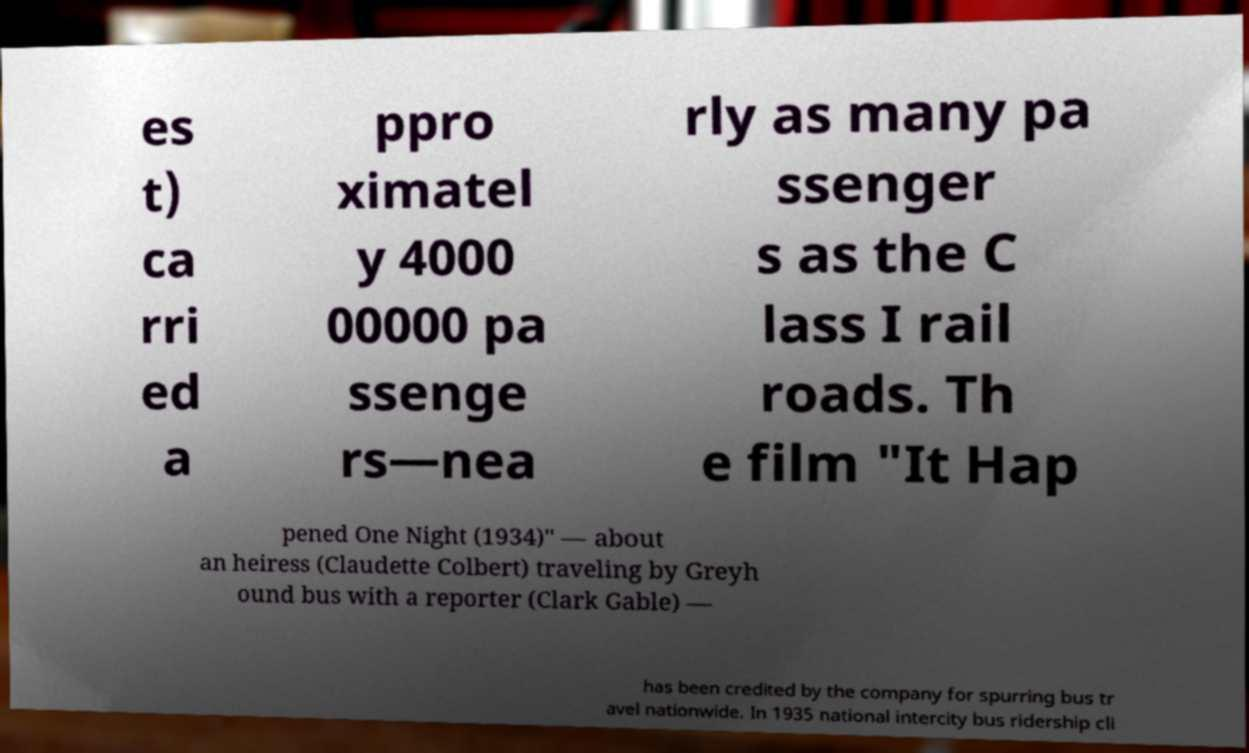Please read and relay the text visible in this image. What does it say? es t) ca rri ed a ppro ximatel y 4000 00000 pa ssenge rs—nea rly as many pa ssenger s as the C lass I rail roads. Th e film "It Hap pened One Night (1934)" — about an heiress (Claudette Colbert) traveling by Greyh ound bus with a reporter (Clark Gable) — has been credited by the company for spurring bus tr avel nationwide. In 1935 national intercity bus ridership cli 